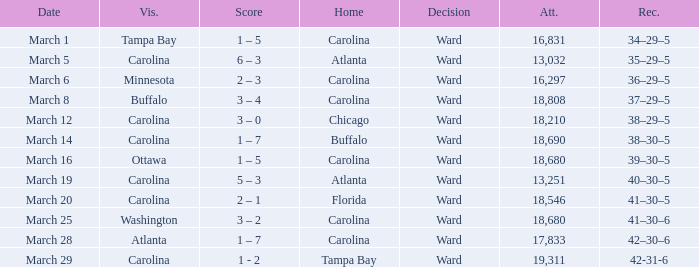What is the Record when Buffalo is at Home? 38–30–5. 